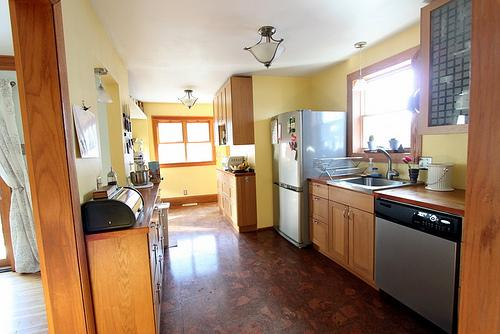What type of furniture can be found below the sink and what information about it can be deduced from the image? Cabinets can be found below the sink, and they appear to have door handles and be made of wood. What type of object can be found on the window sill, and what activity might require their presence? Plants are found on the window sill, possibly for decorative purposes or to receive sunlight for their growth. Name the appliance that can be found next to the wall, and describe its appearance. The fridge is located next to the wall, and it has a silver-grey appearance with multiple decorations on it. Describe one interesting detail about the floor, as per the given information. The floor is brown, and there is a light reflection visible on its surface. Mention any decorative items on the refrigerator and the type of decorations they are. There are magnets and stickers on the fridge, serving as decorative items. Identify the object situated next to the cabinets and describe its color and features. The dishwasher next to the cabinets is grey and black, with a panel of buttons and silver knobs. Explain the source of light in the image and where it is coming from. Sunlight is coming through the window, creating light reflections on the table, floor, and ceiling. 